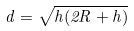Convert formula to latex. <formula><loc_0><loc_0><loc_500><loc_500>d = \sqrt { h ( 2 R + h ) }</formula> 